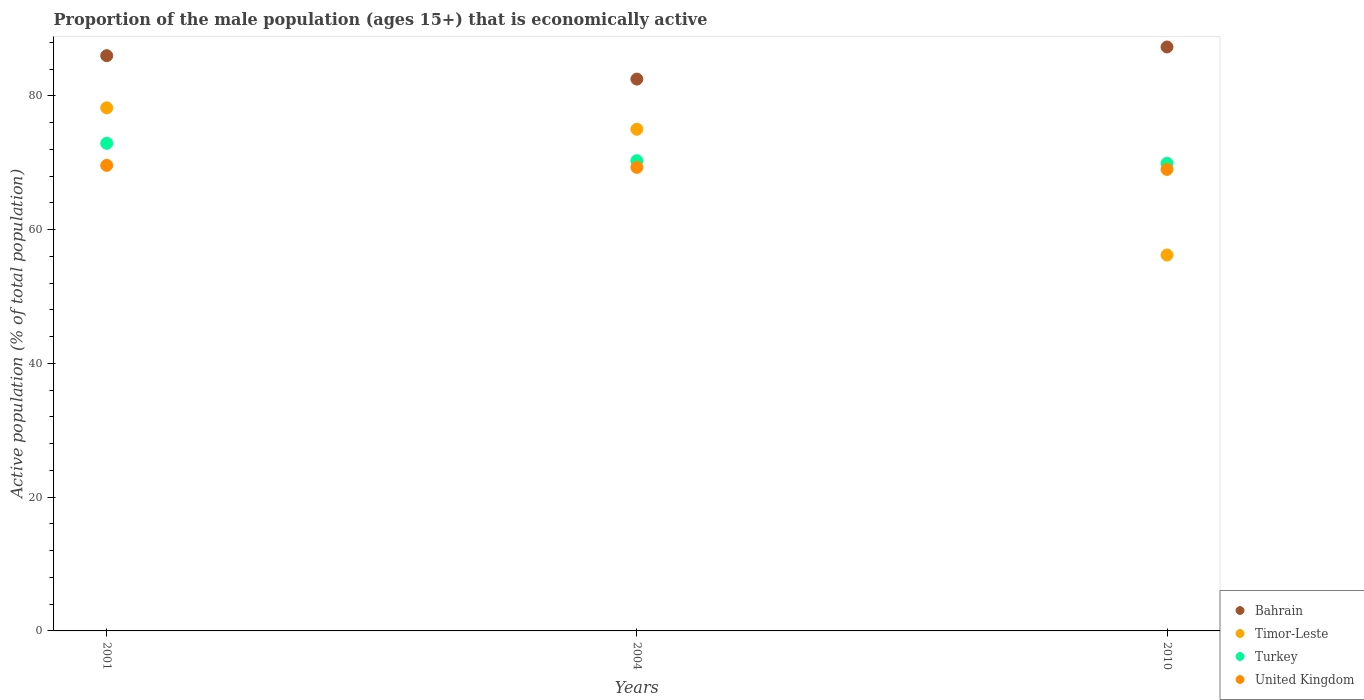What is the proportion of the male population that is economically active in Bahrain in 2010?
Offer a terse response. 87.3. Across all years, what is the maximum proportion of the male population that is economically active in Timor-Leste?
Keep it short and to the point. 78.2. In which year was the proportion of the male population that is economically active in Turkey maximum?
Provide a succinct answer. 2001. In which year was the proportion of the male population that is economically active in United Kingdom minimum?
Give a very brief answer. 2010. What is the total proportion of the male population that is economically active in Turkey in the graph?
Your response must be concise. 213.1. What is the difference between the proportion of the male population that is economically active in Turkey in 2004 and that in 2010?
Provide a short and direct response. 0.4. What is the difference between the proportion of the male population that is economically active in Turkey in 2004 and the proportion of the male population that is economically active in Bahrain in 2001?
Your answer should be very brief. -15.7. What is the average proportion of the male population that is economically active in United Kingdom per year?
Your answer should be compact. 69.3. In the year 2010, what is the difference between the proportion of the male population that is economically active in United Kingdom and proportion of the male population that is economically active in Bahrain?
Give a very brief answer. -18.3. In how many years, is the proportion of the male population that is economically active in Timor-Leste greater than 52 %?
Offer a very short reply. 3. What is the ratio of the proportion of the male population that is economically active in United Kingdom in 2001 to that in 2004?
Offer a very short reply. 1. What is the difference between the highest and the second highest proportion of the male population that is economically active in United Kingdom?
Your response must be concise. 0.3. What is the difference between the highest and the lowest proportion of the male population that is economically active in Timor-Leste?
Make the answer very short. 22. Does the proportion of the male population that is economically active in United Kingdom monotonically increase over the years?
Ensure brevity in your answer.  No. Is the proportion of the male population that is economically active in United Kingdom strictly greater than the proportion of the male population that is economically active in Turkey over the years?
Make the answer very short. No. Is the proportion of the male population that is economically active in Bahrain strictly less than the proportion of the male population that is economically active in Turkey over the years?
Your answer should be very brief. No. How many dotlines are there?
Give a very brief answer. 4. How many years are there in the graph?
Keep it short and to the point. 3. How are the legend labels stacked?
Give a very brief answer. Vertical. What is the title of the graph?
Ensure brevity in your answer.  Proportion of the male population (ages 15+) that is economically active. What is the label or title of the X-axis?
Your answer should be very brief. Years. What is the label or title of the Y-axis?
Your answer should be compact. Active population (% of total population). What is the Active population (% of total population) of Bahrain in 2001?
Offer a very short reply. 86. What is the Active population (% of total population) of Timor-Leste in 2001?
Offer a terse response. 78.2. What is the Active population (% of total population) in Turkey in 2001?
Make the answer very short. 72.9. What is the Active population (% of total population) of United Kingdom in 2001?
Make the answer very short. 69.6. What is the Active population (% of total population) of Bahrain in 2004?
Your answer should be compact. 82.5. What is the Active population (% of total population) of Timor-Leste in 2004?
Provide a short and direct response. 75. What is the Active population (% of total population) of Turkey in 2004?
Give a very brief answer. 70.3. What is the Active population (% of total population) of United Kingdom in 2004?
Provide a short and direct response. 69.3. What is the Active population (% of total population) in Bahrain in 2010?
Offer a terse response. 87.3. What is the Active population (% of total population) of Timor-Leste in 2010?
Keep it short and to the point. 56.2. What is the Active population (% of total population) in Turkey in 2010?
Ensure brevity in your answer.  69.9. What is the Active population (% of total population) of United Kingdom in 2010?
Give a very brief answer. 69. Across all years, what is the maximum Active population (% of total population) in Bahrain?
Your answer should be very brief. 87.3. Across all years, what is the maximum Active population (% of total population) in Timor-Leste?
Give a very brief answer. 78.2. Across all years, what is the maximum Active population (% of total population) in Turkey?
Your response must be concise. 72.9. Across all years, what is the maximum Active population (% of total population) in United Kingdom?
Provide a short and direct response. 69.6. Across all years, what is the minimum Active population (% of total population) in Bahrain?
Provide a short and direct response. 82.5. Across all years, what is the minimum Active population (% of total population) of Timor-Leste?
Provide a short and direct response. 56.2. Across all years, what is the minimum Active population (% of total population) in Turkey?
Offer a very short reply. 69.9. Across all years, what is the minimum Active population (% of total population) of United Kingdom?
Your response must be concise. 69. What is the total Active population (% of total population) of Bahrain in the graph?
Your answer should be compact. 255.8. What is the total Active population (% of total population) in Timor-Leste in the graph?
Provide a succinct answer. 209.4. What is the total Active population (% of total population) of Turkey in the graph?
Your answer should be compact. 213.1. What is the total Active population (% of total population) in United Kingdom in the graph?
Your response must be concise. 207.9. What is the difference between the Active population (% of total population) in Bahrain in 2001 and that in 2004?
Your answer should be very brief. 3.5. What is the difference between the Active population (% of total population) of Timor-Leste in 2001 and that in 2004?
Your answer should be very brief. 3.2. What is the difference between the Active population (% of total population) of Turkey in 2001 and that in 2004?
Provide a succinct answer. 2.6. What is the difference between the Active population (% of total population) in United Kingdom in 2001 and that in 2004?
Ensure brevity in your answer.  0.3. What is the difference between the Active population (% of total population) in Bahrain in 2001 and that in 2010?
Offer a terse response. -1.3. What is the difference between the Active population (% of total population) of United Kingdom in 2001 and that in 2010?
Make the answer very short. 0.6. What is the difference between the Active population (% of total population) of Timor-Leste in 2004 and that in 2010?
Your answer should be very brief. 18.8. What is the difference between the Active population (% of total population) of United Kingdom in 2004 and that in 2010?
Provide a short and direct response. 0.3. What is the difference between the Active population (% of total population) of Timor-Leste in 2001 and the Active population (% of total population) of United Kingdom in 2004?
Offer a very short reply. 8.9. What is the difference between the Active population (% of total population) in Bahrain in 2001 and the Active population (% of total population) in Timor-Leste in 2010?
Offer a terse response. 29.8. What is the difference between the Active population (% of total population) in Bahrain in 2001 and the Active population (% of total population) in Turkey in 2010?
Keep it short and to the point. 16.1. What is the difference between the Active population (% of total population) of Bahrain in 2001 and the Active population (% of total population) of United Kingdom in 2010?
Your response must be concise. 17. What is the difference between the Active population (% of total population) in Timor-Leste in 2001 and the Active population (% of total population) in United Kingdom in 2010?
Offer a terse response. 9.2. What is the difference between the Active population (% of total population) of Turkey in 2001 and the Active population (% of total population) of United Kingdom in 2010?
Keep it short and to the point. 3.9. What is the difference between the Active population (% of total population) of Bahrain in 2004 and the Active population (% of total population) of Timor-Leste in 2010?
Your response must be concise. 26.3. What is the difference between the Active population (% of total population) of Timor-Leste in 2004 and the Active population (% of total population) of Turkey in 2010?
Your response must be concise. 5.1. What is the difference between the Active population (% of total population) of Turkey in 2004 and the Active population (% of total population) of United Kingdom in 2010?
Provide a succinct answer. 1.3. What is the average Active population (% of total population) of Bahrain per year?
Offer a very short reply. 85.27. What is the average Active population (% of total population) in Timor-Leste per year?
Your response must be concise. 69.8. What is the average Active population (% of total population) in Turkey per year?
Provide a succinct answer. 71.03. What is the average Active population (% of total population) in United Kingdom per year?
Your answer should be compact. 69.3. In the year 2001, what is the difference between the Active population (% of total population) in Bahrain and Active population (% of total population) in Timor-Leste?
Provide a succinct answer. 7.8. In the year 2004, what is the difference between the Active population (% of total population) in Bahrain and Active population (% of total population) in Timor-Leste?
Give a very brief answer. 7.5. In the year 2004, what is the difference between the Active population (% of total population) in Bahrain and Active population (% of total population) in Turkey?
Offer a very short reply. 12.2. In the year 2004, what is the difference between the Active population (% of total population) of Timor-Leste and Active population (% of total population) of Turkey?
Offer a terse response. 4.7. In the year 2004, what is the difference between the Active population (% of total population) of Timor-Leste and Active population (% of total population) of United Kingdom?
Offer a terse response. 5.7. In the year 2004, what is the difference between the Active population (% of total population) in Turkey and Active population (% of total population) in United Kingdom?
Make the answer very short. 1. In the year 2010, what is the difference between the Active population (% of total population) in Bahrain and Active population (% of total population) in Timor-Leste?
Your answer should be compact. 31.1. In the year 2010, what is the difference between the Active population (% of total population) of Bahrain and Active population (% of total population) of United Kingdom?
Provide a succinct answer. 18.3. In the year 2010, what is the difference between the Active population (% of total population) in Timor-Leste and Active population (% of total population) in Turkey?
Offer a very short reply. -13.7. In the year 2010, what is the difference between the Active population (% of total population) of Timor-Leste and Active population (% of total population) of United Kingdom?
Make the answer very short. -12.8. What is the ratio of the Active population (% of total population) in Bahrain in 2001 to that in 2004?
Provide a short and direct response. 1.04. What is the ratio of the Active population (% of total population) in Timor-Leste in 2001 to that in 2004?
Give a very brief answer. 1.04. What is the ratio of the Active population (% of total population) in Turkey in 2001 to that in 2004?
Give a very brief answer. 1.04. What is the ratio of the Active population (% of total population) of Bahrain in 2001 to that in 2010?
Provide a succinct answer. 0.99. What is the ratio of the Active population (% of total population) of Timor-Leste in 2001 to that in 2010?
Your answer should be compact. 1.39. What is the ratio of the Active population (% of total population) in Turkey in 2001 to that in 2010?
Keep it short and to the point. 1.04. What is the ratio of the Active population (% of total population) of United Kingdom in 2001 to that in 2010?
Keep it short and to the point. 1.01. What is the ratio of the Active population (% of total population) in Bahrain in 2004 to that in 2010?
Provide a short and direct response. 0.94. What is the ratio of the Active population (% of total population) in Timor-Leste in 2004 to that in 2010?
Provide a short and direct response. 1.33. What is the difference between the highest and the second highest Active population (% of total population) in Turkey?
Ensure brevity in your answer.  2.6. What is the difference between the highest and the second highest Active population (% of total population) in United Kingdom?
Provide a succinct answer. 0.3. What is the difference between the highest and the lowest Active population (% of total population) in Timor-Leste?
Ensure brevity in your answer.  22. What is the difference between the highest and the lowest Active population (% of total population) in Turkey?
Offer a terse response. 3. 